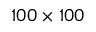<formula> <loc_0><loc_0><loc_500><loc_500>1 0 0 \times 1 0 0</formula> 